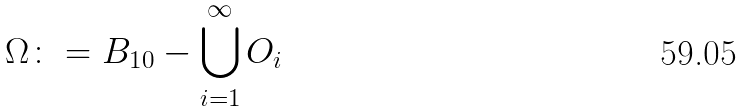Convert formula to latex. <formula><loc_0><loc_0><loc_500><loc_500>\Omega \colon = B _ { 1 0 } - \bigcup _ { i = 1 } ^ { \infty } O _ { i }</formula> 